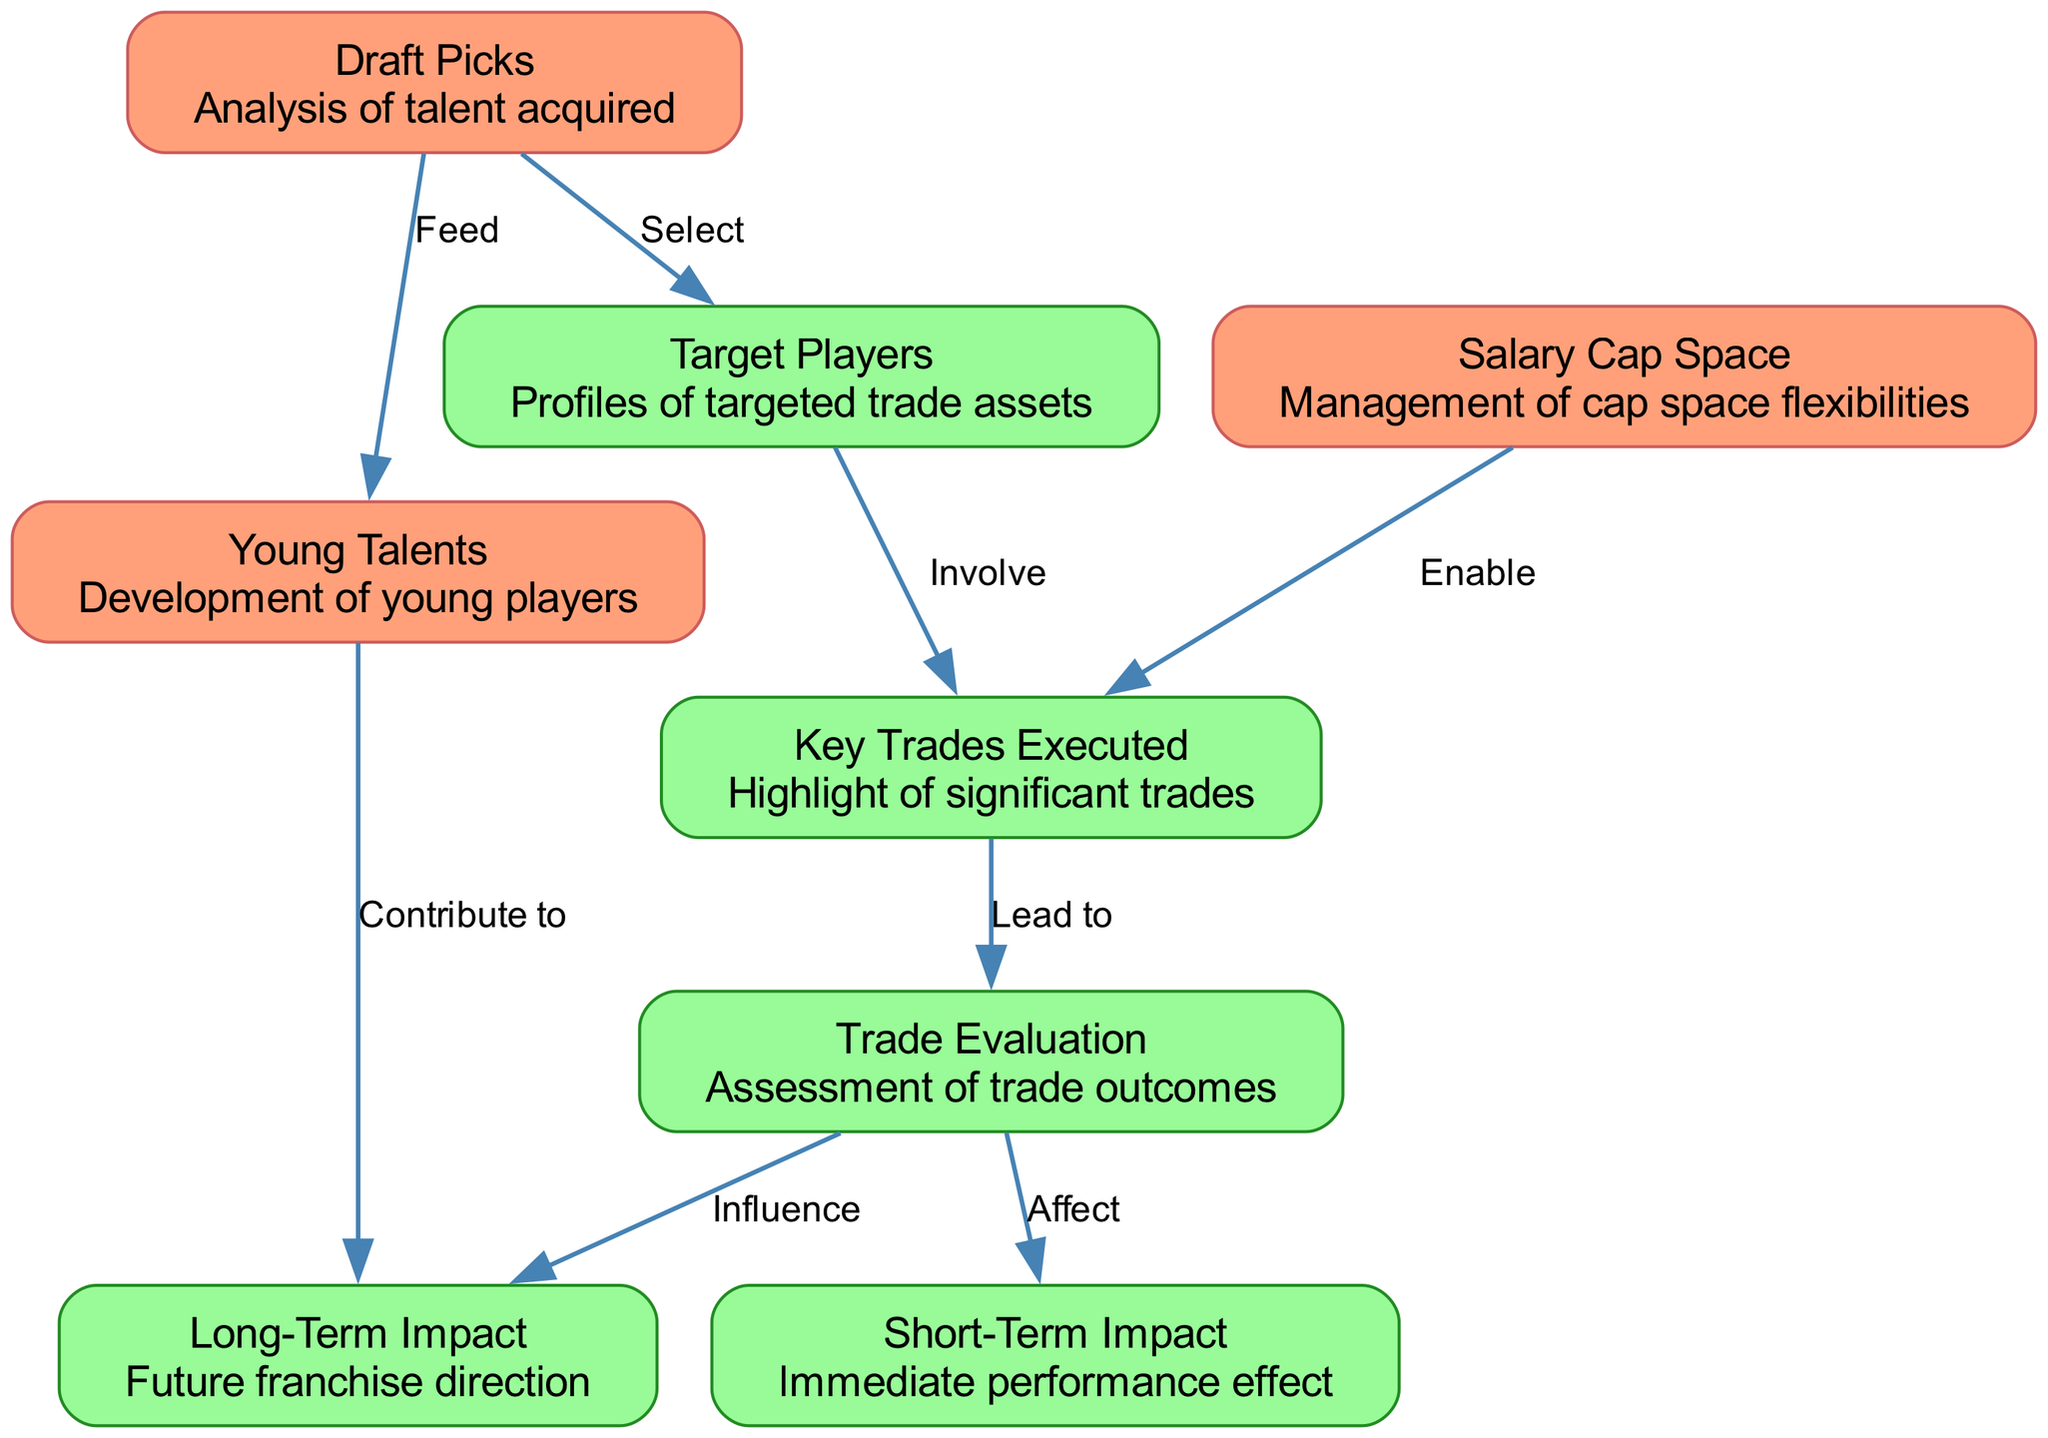What are the main types of items analyzed in the diagram? The diagram focuses on Draft Picks, Young Talents, Salary Cap Space, Key Trades Executed, Trade Evaluation, Short-Term Impact, Long-Term Impact, and Target Players. These categories represent the primary nodes in the analysis.
Answer: Draft Picks, Young Talents, Salary Cap Space, Key Trades Executed, Trade Evaluation, Short-Term Impact, Long-Term Impact, Target Players How many edges are present in the diagram? The diagram includes a total of seven edges connecting various nodes, which illustrate relationships such as influence and contribution.
Answer: Seven What does "Trade Evaluation" impact according to the diagram? The Trade Evaluation node directly affects both Short-Term Impact and Long-Term Impact based on the directional edges leading from Trade Evaluation to these nodes.
Answer: Short-Term Impact, Long-Term Impact Which node feeds into the "Young Talents" node? According to the diagram, the "Draft Picks" node feeds into the "Young Talents," indicating that draft picks contribute to developing young players, as shown by the edge connection.
Answer: Draft Picks What enables the execution of "Key Trades"? The "Salary Cap Space" node is responsible for enabling "Key Trades," suggesting that having sufficient salary cap flexibility allows the team to make significant trades.
Answer: Salary Cap Space How do "Rockets Picks" relate to "Target Players"? "Rockets Picks" have a direct selection relationship with "Target Players," as indicated by the edge labeled "Select," meaning that draft decisions directly influence the target player profiles for trades.
Answer: Select Which node contributes to the "Long-Term Impact"? The node "Young Talents" makes a direct contribution to the "Long-Term Impact," suggesting that the development of young players is essential for the future direction of the franchise.
Answer: Young Talents 